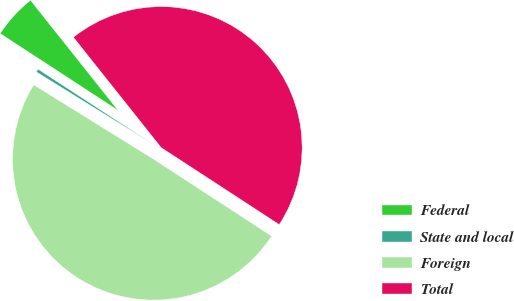<chart> <loc_0><loc_0><loc_500><loc_500><pie_chart><fcel>Federal<fcel>State and local<fcel>Foreign<fcel>Total<nl><fcel>5.11%<fcel>0.37%<fcel>49.63%<fcel>44.89%<nl></chart> 